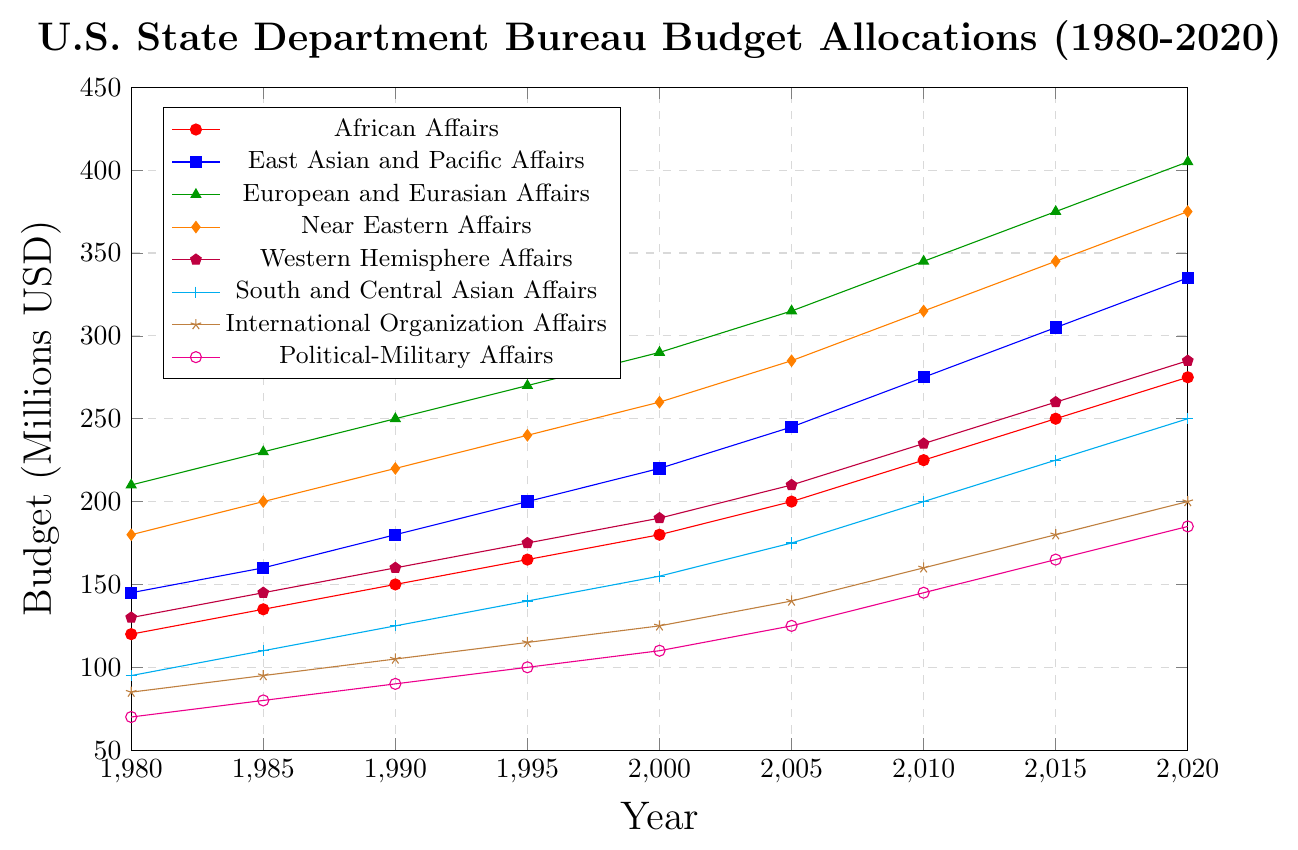Which bureau received the highest budget in 2020? Look at the values at the year 2020 and compare them across the different bureaus. The Bureau of European and Eurasian Affairs has the highest value of 405.
Answer: Bureau of European and Eurasian Affairs What is the total budget allocation for the Bureau of International Organization Affairs from 1980 to 2020? Sum the values for the Bureau of International Organization Affairs over the years: 85 + 95 + 105 + 115 + 125 + 140 + 160 + 180 + 200 = 1205.
Answer: 1205 Which bureau's budget grew the most between 1980 and 2020? Subtract the 1980 value from the 2020 value for each bureau and find the maximum difference. The Bureau of European and Eurasian Affairs grew from 210 to 405, an increase of 195 which is the largest.
Answer: Bureau of European and Eurasian Affairs In which year did the Bureau of Political-Military Affairs first surpass a budget of 150 million USD? Look for the first instance in the Bureau of Political-Military Affairs' values where the budget is greater than 150. This happens in 2010 with a budget of 145.
Answer: 2010 What is the average budget allocation for the Bureau of Near Eastern Affairs over the 40-year period? Take the sum of the Bureau of Near Eastern Affairs' budgets and divide by the number of years: (180 + 200 + 220 + 240 + 260 + 285 + 315 + 345 + 375) / 9 = 269.
Answer: 269 Compare the budget allocations between Bureau of African Affairs and Bureau of South and Central Asian Affairs in 2000. Which one was higher? Compare the values in 2000 for both bureaus: Bureau of African Affairs is 180 and Bureau of South and Central Asian Affairs is 155.
Answer: Bureau of African Affairs In which year did the Bureau of East Asian and Pacific Affairs have a budget exactly equal to the Bureau of Western Hemisphere Affairs? Look at the values year by year to find any matching values. Both bureaus have a budget of 145 million USD in 1985.
Answer: 1985 What is the median budget allocation for the Bureau of Western Hemisphere Affairs from 1980 to 2020? Sort the Bureau of Western Hemisphere Affairs' values and find the median: (130, 145, 160, 175, 190, 210, 235, 260, 285). The middle value is 190.
Answer: 190 Between 1995 and 2015, which bureau saw the smallest increase in budget allocation? Calculate the increase for each bureau over the period: Bureau of African Affairs: 250-165=85, Bureau of East Asian and Pacific Affairs: 305-200=105, Bureau of European and Eurasian Affairs: 375-270=105, Bureau of Near Eastern Affairs: 345-240=105, Bureau of Western Hemisphere Affairs: 260-175=85, Bureau of South and Central Asian Affairs: 225-140=85, Bureau of International Organization Affairs: 180-115=65, Bureau of Political-Military Affairs: 165-100=65. The smallest increases are for International Organization Affairs and Political-Military Affairs, both 65 million USD.
Answer: Bureau of International Organization Affairs and Bureau of Political-Military Affairs 